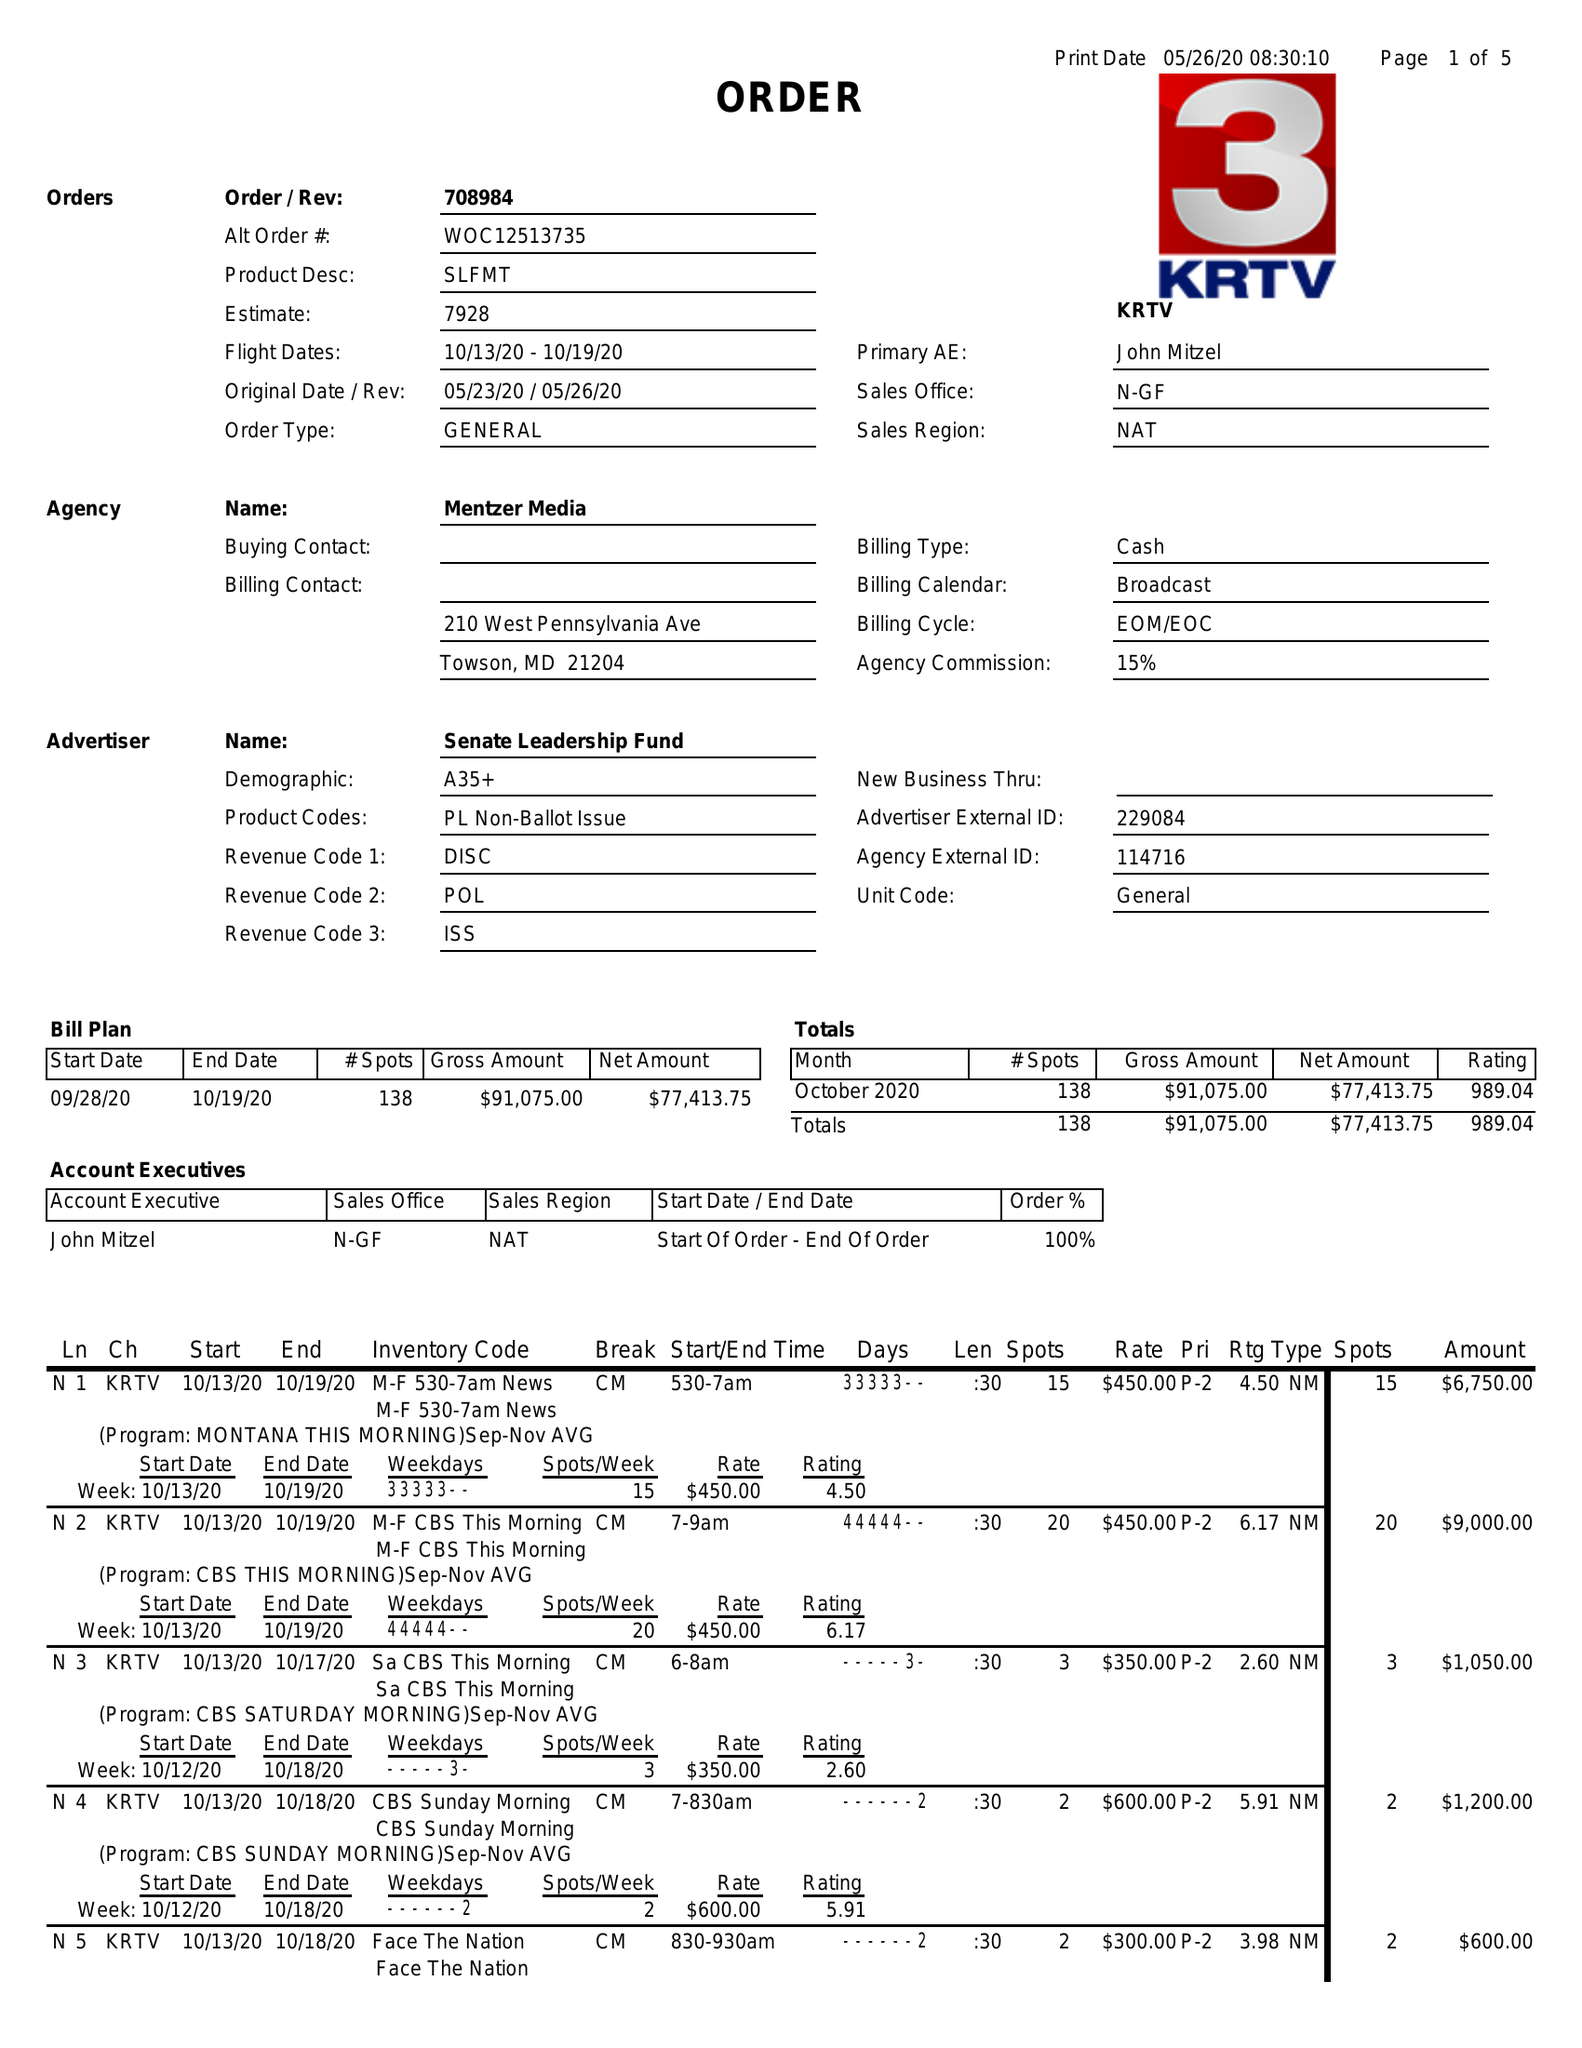What is the value for the advertiser?
Answer the question using a single word or phrase. SENATE LEADERSHIP FUND 